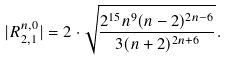<formula> <loc_0><loc_0><loc_500><loc_500>| R _ { 2 , 1 } ^ { n , 0 } | = 2 \cdot \sqrt { \frac { 2 ^ { 1 5 } n ^ { 9 } ( n - 2 ) ^ { 2 n - 6 } } { 3 ( n + 2 ) ^ { 2 n + 6 } } } .</formula> 